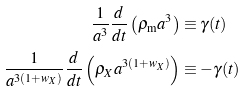Convert formula to latex. <formula><loc_0><loc_0><loc_500><loc_500>\frac { 1 } { a ^ { 3 } } \frac { d } { d t } \left ( \rho _ { \text {m} } a ^ { 3 } \right ) & \equiv \gamma ( t ) \\ \frac { 1 } { a ^ { 3 ( 1 + w _ { X } ) } } \frac { d } { d t } \left ( \rho _ { X } a ^ { 3 ( 1 + w _ { X } ) } \right ) & \equiv - \gamma ( t )</formula> 